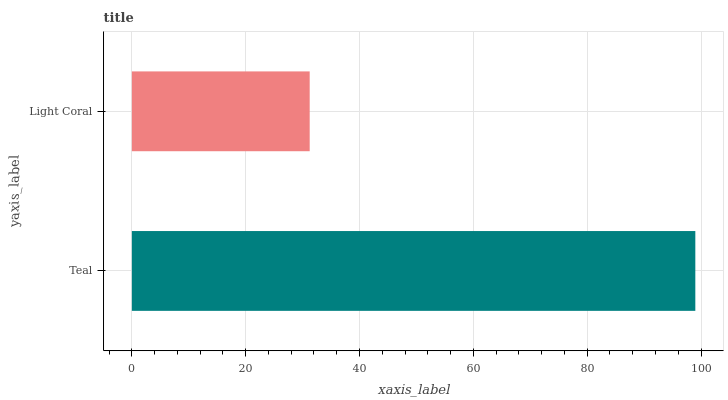Is Light Coral the minimum?
Answer yes or no. Yes. Is Teal the maximum?
Answer yes or no. Yes. Is Light Coral the maximum?
Answer yes or no. No. Is Teal greater than Light Coral?
Answer yes or no. Yes. Is Light Coral less than Teal?
Answer yes or no. Yes. Is Light Coral greater than Teal?
Answer yes or no. No. Is Teal less than Light Coral?
Answer yes or no. No. Is Teal the high median?
Answer yes or no. Yes. Is Light Coral the low median?
Answer yes or no. Yes. Is Light Coral the high median?
Answer yes or no. No. Is Teal the low median?
Answer yes or no. No. 